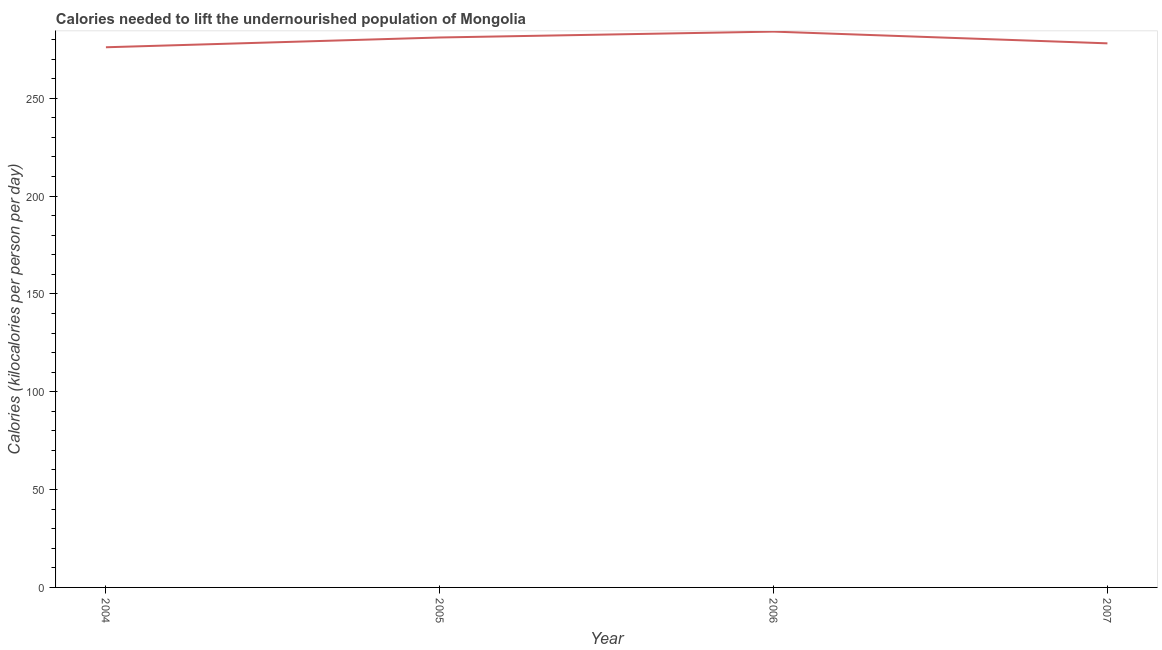What is the depth of food deficit in 2007?
Ensure brevity in your answer.  278. Across all years, what is the maximum depth of food deficit?
Provide a succinct answer. 284. Across all years, what is the minimum depth of food deficit?
Offer a very short reply. 276. In which year was the depth of food deficit minimum?
Your answer should be very brief. 2004. What is the sum of the depth of food deficit?
Ensure brevity in your answer.  1119. What is the difference between the depth of food deficit in 2004 and 2006?
Give a very brief answer. -8. What is the average depth of food deficit per year?
Your answer should be very brief. 279.75. What is the median depth of food deficit?
Provide a succinct answer. 279.5. Do a majority of the years between 2006 and 2007 (inclusive) have depth of food deficit greater than 70 kilocalories?
Provide a short and direct response. Yes. What is the ratio of the depth of food deficit in 2004 to that in 2007?
Offer a very short reply. 0.99. Is the depth of food deficit in 2005 less than that in 2006?
Provide a short and direct response. Yes. What is the difference between the highest and the second highest depth of food deficit?
Offer a terse response. 3. Is the sum of the depth of food deficit in 2004 and 2006 greater than the maximum depth of food deficit across all years?
Offer a terse response. Yes. What is the difference between the highest and the lowest depth of food deficit?
Your answer should be compact. 8. In how many years, is the depth of food deficit greater than the average depth of food deficit taken over all years?
Keep it short and to the point. 2. Does the depth of food deficit monotonically increase over the years?
Give a very brief answer. No. How many years are there in the graph?
Offer a very short reply. 4. Are the values on the major ticks of Y-axis written in scientific E-notation?
Your response must be concise. No. Does the graph contain any zero values?
Keep it short and to the point. No. What is the title of the graph?
Provide a short and direct response. Calories needed to lift the undernourished population of Mongolia. What is the label or title of the Y-axis?
Give a very brief answer. Calories (kilocalories per person per day). What is the Calories (kilocalories per person per day) of 2004?
Offer a very short reply. 276. What is the Calories (kilocalories per person per day) of 2005?
Keep it short and to the point. 281. What is the Calories (kilocalories per person per day) in 2006?
Your answer should be very brief. 284. What is the Calories (kilocalories per person per day) in 2007?
Provide a short and direct response. 278. What is the difference between the Calories (kilocalories per person per day) in 2004 and 2006?
Make the answer very short. -8. What is the difference between the Calories (kilocalories per person per day) in 2005 and 2006?
Provide a succinct answer. -3. What is the ratio of the Calories (kilocalories per person per day) in 2004 to that in 2006?
Ensure brevity in your answer.  0.97. What is the ratio of the Calories (kilocalories per person per day) in 2005 to that in 2006?
Your response must be concise. 0.99. What is the ratio of the Calories (kilocalories per person per day) in 2006 to that in 2007?
Offer a very short reply. 1.02. 